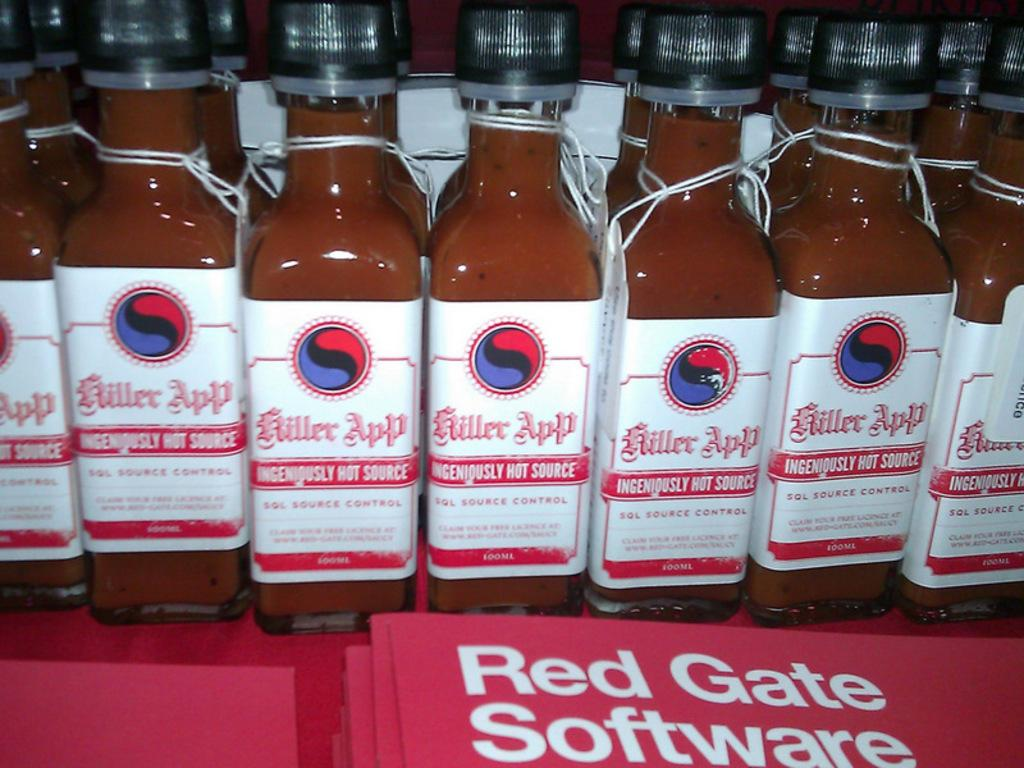What objects are present in the image? There are bottles in the image. Can you see a monkey holding a pear while joining the bottles in the image? There is no monkey, pear, or any indication of joining the bottles in the image; it only features bottles. 